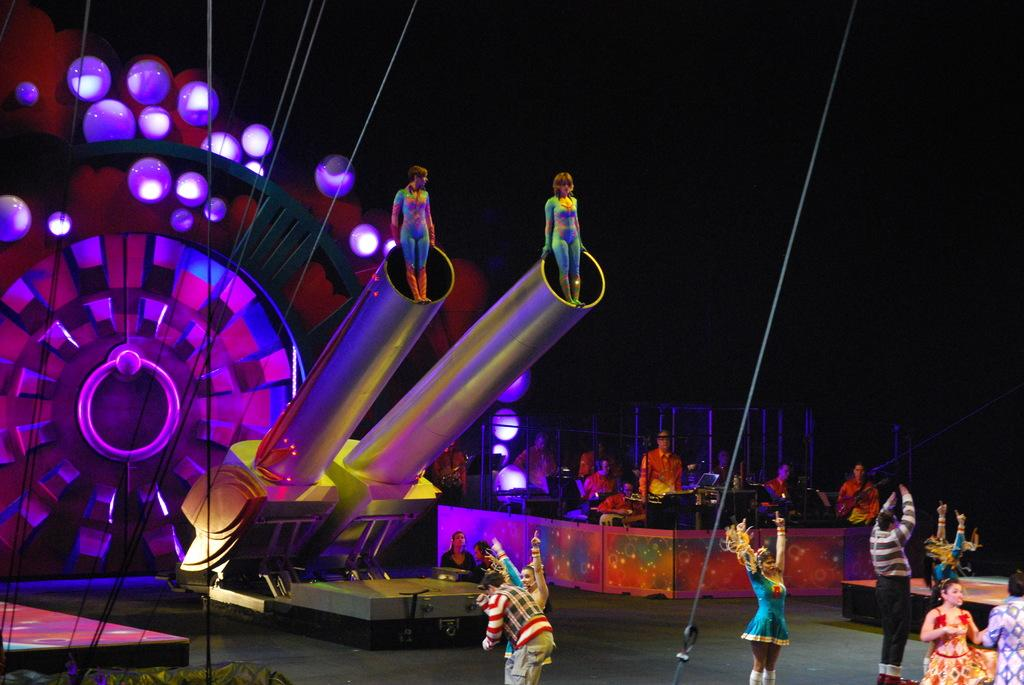How many people are in the image? There are people in the image, but the exact number cannot be determined from the provided facts. What objects are present in the image besides the people? There are ropes in the image. However, the number of ropes cannot be determined from the provided facts. What type of arch can be seen in the image? There is no arch present in the image. What type of cloth is draped over the people in the image? There is no cloth draped over the people in the image. 